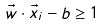Convert formula to latex. <formula><loc_0><loc_0><loc_500><loc_500>\vec { w } \cdot \vec { x } _ { i } - b \geq 1</formula> 